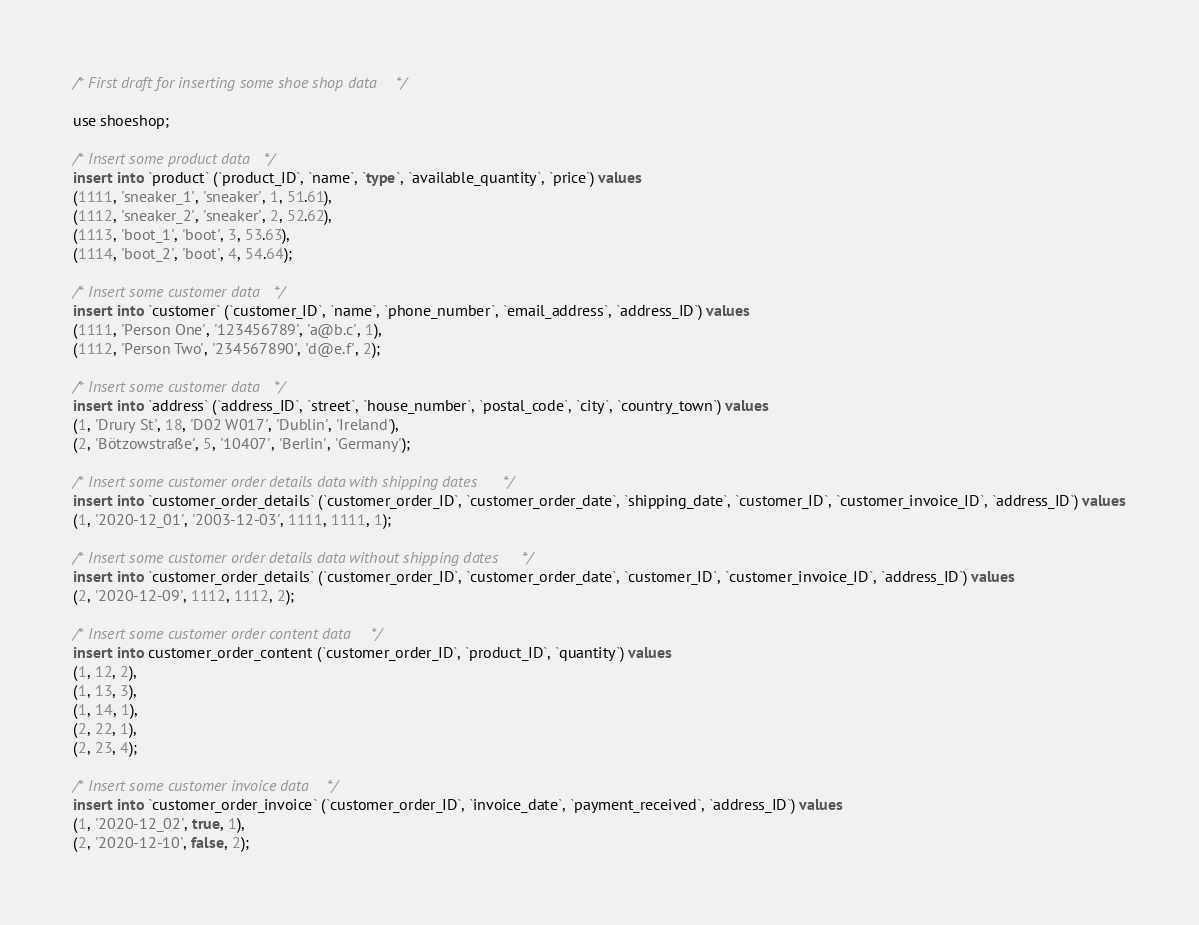<code> <loc_0><loc_0><loc_500><loc_500><_SQL_>/* First draft for inserting some shoe shop data */

use shoeshop;

/* Insert some product data */
insert into `product` (`product_ID`, `name`, `type`, `available_quantity`, `price`) values
(1111, 'sneaker_1', 'sneaker', 1, 51.61),
(1112, 'sneaker_2', 'sneaker', 2, 52.62),
(1113, 'boot_1', 'boot', 3, 53.63),
(1114, 'boot_2', 'boot', 4, 54.64);

/* Insert some customer data */
insert into `customer` (`customer_ID`, `name`, `phone_number`, `email_address`, `address_ID`) values
(1111, 'Person One', '123456789', 'a@b.c', 1),
(1112, 'Person Two', '234567890', 'd@e.f', 2);

/* Insert some customer data */
insert into `address` (`address_ID`, `street`, `house_number`, `postal_code`, `city`, `country_town`) values
(1, 'Drury St', 18, 'D02 W017', 'Dublin', 'Ireland'),
(2, 'Bötzowstraße', 5, '10407', 'Berlin', 'Germany');

/* Insert some customer order details data with shipping dates */
insert into `customer_order_details` (`customer_order_ID`, `customer_order_date`, `shipping_date`, `customer_ID`, `customer_invoice_ID`, `address_ID`) values
(1, '2020-12_01', '2003-12-03', 1111, 1111, 1);

/* Insert some customer order details data without shipping dates*/
insert into `customer_order_details` (`customer_order_ID`, `customer_order_date`, `customer_ID`, `customer_invoice_ID`, `address_ID`) values
(2, '2020-12-09', 1112, 1112, 2);

/* Insert some customer order content data */
insert into customer_order_content (`customer_order_ID`, `product_ID`, `quantity`) values
(1, 12, 2),
(1, 13, 3),
(1, 14, 1),
(2, 22, 1),
(2, 23, 4);

/* Insert some customer invoice data */
insert into `customer_order_invoice` (`customer_order_ID`, `invoice_date`, `payment_received`, `address_ID`) values
(1, '2020-12_02', true, 1),
(2, '2020-12-10', false, 2); 
</code> 